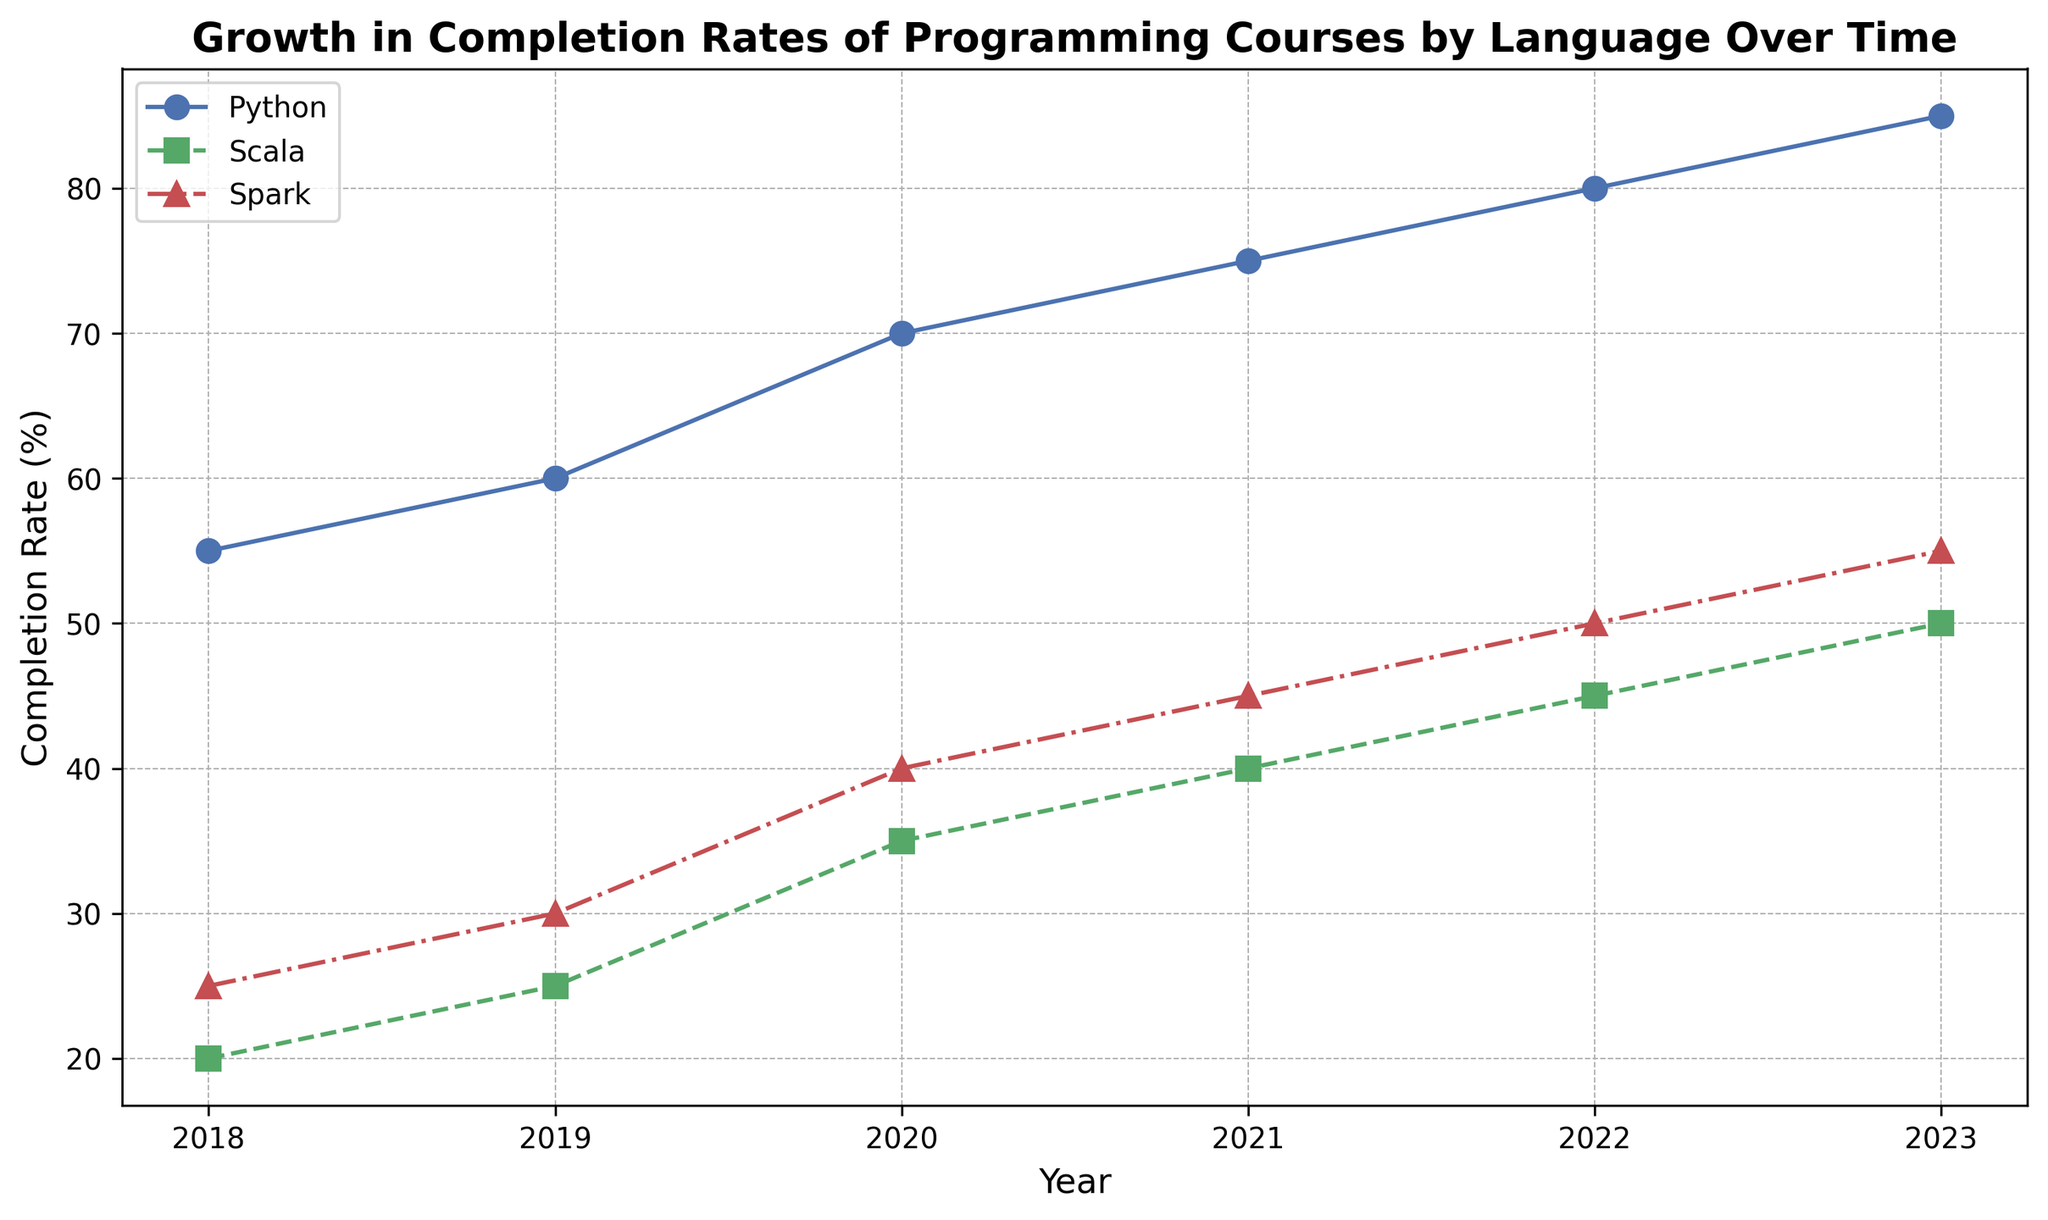What year did Python see the highest completion rate in the data? The chart shows that Python’s completion rate increases over time. The highest value for Python can be observed in the year corresponding to the rightmost end of the Python line.
Answer: 2023 By how much did the completion rate of Scala increase from 2018 to 2021? To find the change in Scala's completion rate, subtract the 2018 value from the 2021 value. According to the chart, Scala had a completion rate of 20% in 2018 and 40% in 2021. So, the increase is 40 - 20.
Answer: 20% Which language had the smallest growth in completion rate from 2018 to 2023? The chart shows the starting and ending points for each language from 2018 to 2023. Python grew from 55 to 85, Scala from 20 to 50, and Spark from 25 to 55. Calculate the growth for each: Python (85-55), Scala (50-20), Spark (55-25). The smallest growth is for Scala.
Answer: Scala In 2020, which language had the highest completion rate? To find the highest completion rate for 2020, compare the values for each language in 2020. According to the chart, Python is highest, followed by Spark and then Scala.
Answer: Python What was the average completion rate of Spark in the years 2021 and 2022? Add the Spark completion rates for 2021 and 2022, then divide by 2. The values are 45 (2021) and 50 (2022). So, (45 + 50) / 2.
Answer: 47.5 How many total completion rate percentage points did Python gain from 2018 to 2019? To find Python's gain, subtract the 2018 value from 2019. The chart shows Python’s rates as 55 in 2018 and 60 in 2019. So, 60 - 55.
Answer: 5 What trend can be observed for the completion rates of Scala from 2018 to 2023? Looking at the chart, Scala's completion rate steadily increases each year with a consistent, upward trend. There are no declines or stagnations observed.
Answer: Steady increase Between Scala and Spark, which had a higher completion rate in 2021? Compare the completion rates of Scala and Spark in 2021 on the chart. Scala had a 40% rate while Spark had a 45% rate.
Answer: Spark Was the completion rate growth of Spark greater or less than Python's from 2019 to 2023? Calculate the growth for Spark (2023 rate - 2019 rate) and for Python (2023 rate - 2019 rate). Spark: 55 - 30, Python: 85 - 60. Compare the two results.
Answer: Less During which years did Python see the same or higher growth in completion rates compared to the previous years? Observe and compare the increment in Python's completion rates year-over-year on the chart. Python's rate increased each year, so identify the years with same or higher increment.
Answer: 2019-to-2020, 2020-to-2021, 2021-to-2022, 2022-to-2023 